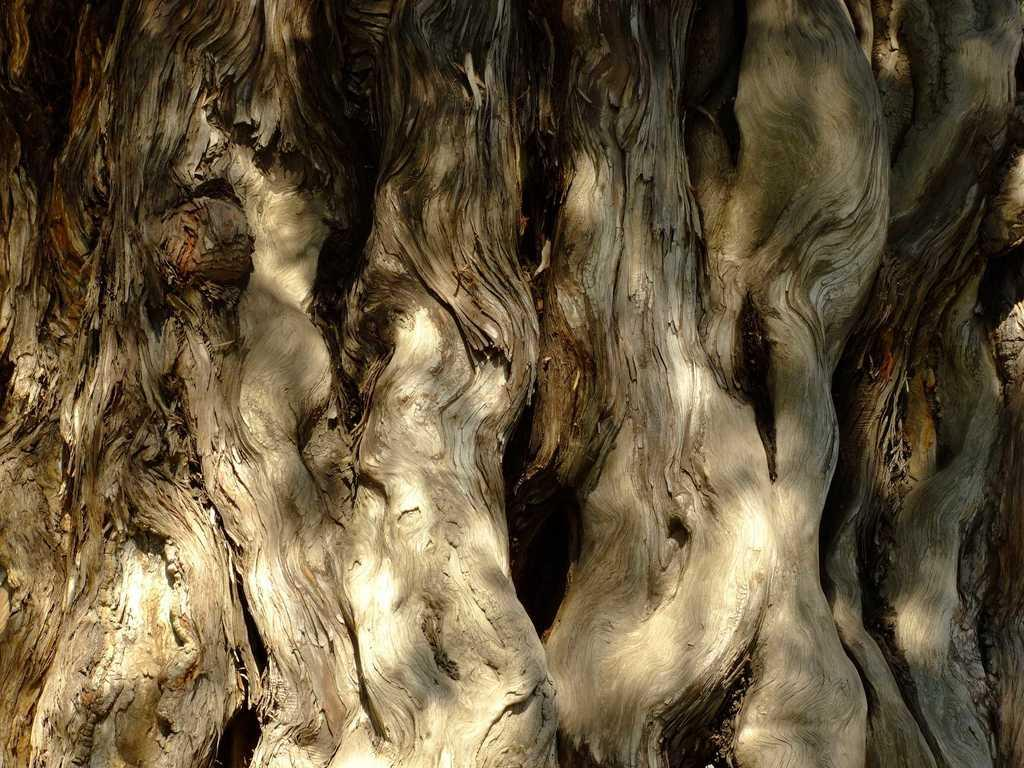What is the main subject of the image? The main subject of the image is a tree trunk. Can you describe the tree trunk in the image? The tree trunk appears to be a large, solid structure in the image. Where is the nearest waste bin to the tree trunk in the image? There is no information about a waste bin in the image, so it cannot be determined from the image. 